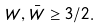<formula> <loc_0><loc_0><loc_500><loc_500>W , \bar { W } \geq 3 / 2 .</formula> 